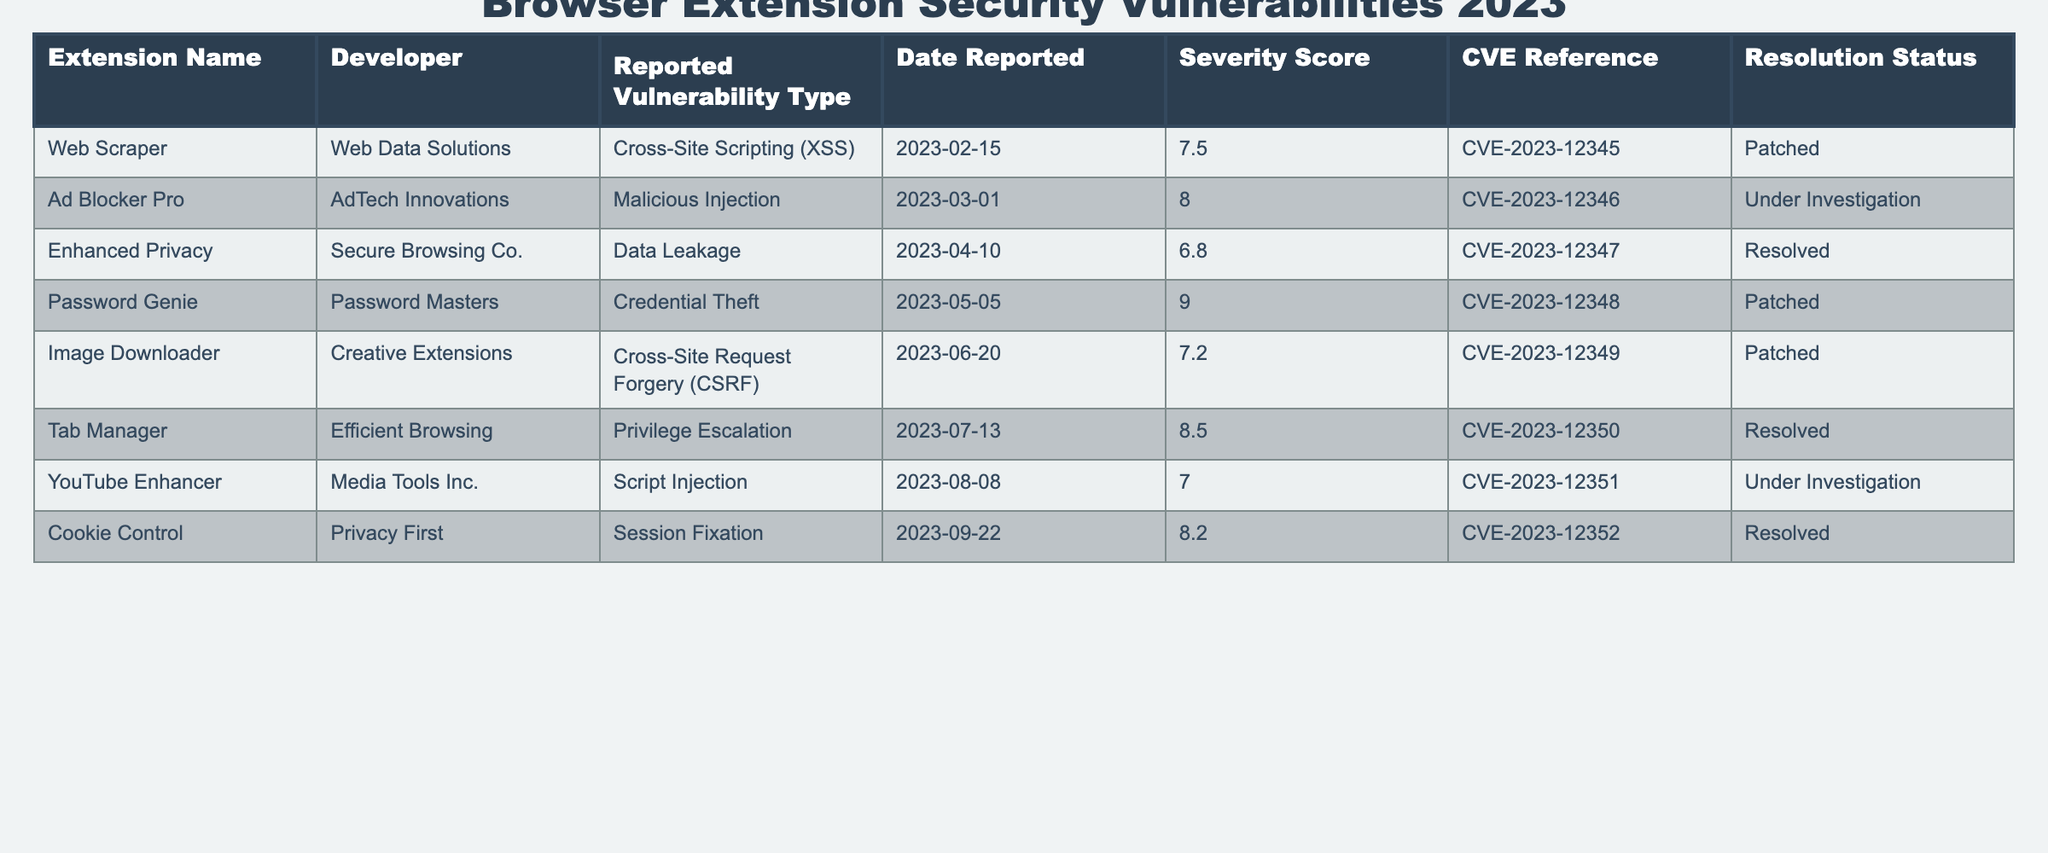What is the severity score of the "Password Genie" extension? The severity score for "Password Genie" can be found in the Severity Score column corresponding to its row in the table. The value listed is 9.0.
Answer: 9.0 Which extension has the highest severity score? By inspecting the Severity Score column and comparing all values, "Password Genie" has the highest severity score of 9.0.
Answer: "Password Genie" Is the vulnerability of "Ad Blocker Pro" resolved? The Resolution Status for "Ad Blocker Pro" is listed as "Under Investigation," indicating that the vulnerability is not yet resolved.
Answer: No How many extensions have been patched? By examining the Resolution Status column, we can count the extensions marked as "Patched." These are "Web Scraper," "Password Genie," and "Image Downloader," totaling three.
Answer: 3 What types of vulnerabilities are reported in 2023? Looking at the Reported Vulnerability Type column, the types of vulnerabilities listed are Cross-Site Scripting (XSS), Malicious Injection, Data Leakage, Credential Theft, Cross-Site Request Forgery (CSRF), Privilege Escalation, Script Injection, and Session Fixation.
Answer: 8 types Which developer resolved the highest number of vulnerabilities? We examine the Resolution Status for each developer's extensions. "Privacy First" resolved one vulnerability while "Secure Browsing Co." resolved one as well. "Password Masters" has one patched vulnerability too. No developer has resolved more than one reported vulnerability.
Answer: Tie between developers with 1 resolution each What was the date when the "Cookie Control" vulnerability was reported? The Date Reported for "Cookie Control" is directly found in its row in the Date Reported column, which shows September 22, 2023.
Answer: 2023-09-22 If we average the severity scores of the resolved vulnerabilities, what would be the result? To find the average severity score of resolved vulnerabilities, we sum the severity scores of "Enhanced Privacy" (6.8), "Tab Manager" (8.5), and "Cookie Control" (8.2). Summing these gives us 6.8 + 8.5 + 8.2 = 23.5. With three resolved vulnerabilities, we find the average as 23.5 / 3 = 7.83.
Answer: 7.83 What is the most common type of vulnerability among the reported extensions? By reviewing the Reported Vulnerability Type column, the most frequent vulnerabilities noted include Cross-Site Scripting (XSS) and Injection types, appearing multiple times. Although individual counts are required, we see at least one of each type listed.
Answer: XSS and Injection types (most common) 